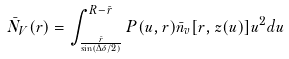Convert formula to latex. <formula><loc_0><loc_0><loc_500><loc_500>\bar { N } _ { V } ( r ) = \int _ { \frac { \bar { r } } { \sin ( \Delta \delta / 2 ) } } ^ { R - \bar { r } } P ( u , r ) \bar { n } _ { v } [ r , z ( u ) ] u ^ { 2 } d u</formula> 